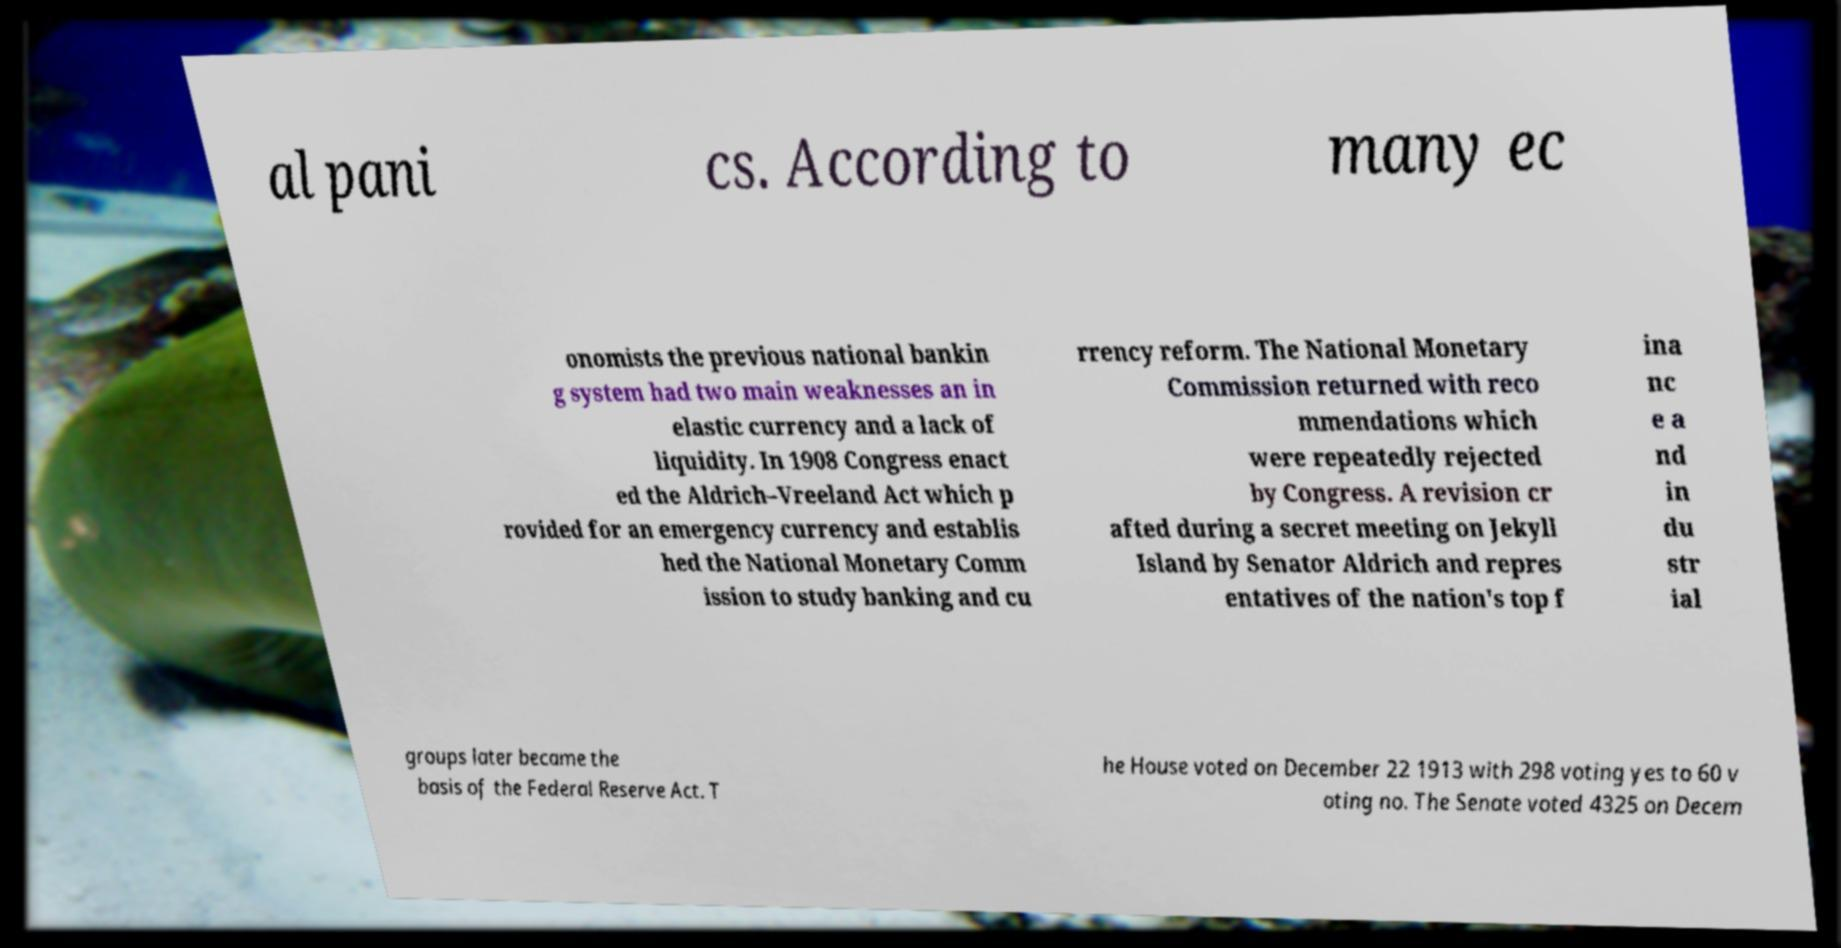Can you read and provide the text displayed in the image?This photo seems to have some interesting text. Can you extract and type it out for me? al pani cs. According to many ec onomists the previous national bankin g system had two main weaknesses an in elastic currency and a lack of liquidity. In 1908 Congress enact ed the Aldrich–Vreeland Act which p rovided for an emergency currency and establis hed the National Monetary Comm ission to study banking and cu rrency reform. The National Monetary Commission returned with reco mmendations which were repeatedly rejected by Congress. A revision cr afted during a secret meeting on Jekyll Island by Senator Aldrich and repres entatives of the nation's top f ina nc e a nd in du str ial groups later became the basis of the Federal Reserve Act. T he House voted on December 22 1913 with 298 voting yes to 60 v oting no. The Senate voted 4325 on Decem 